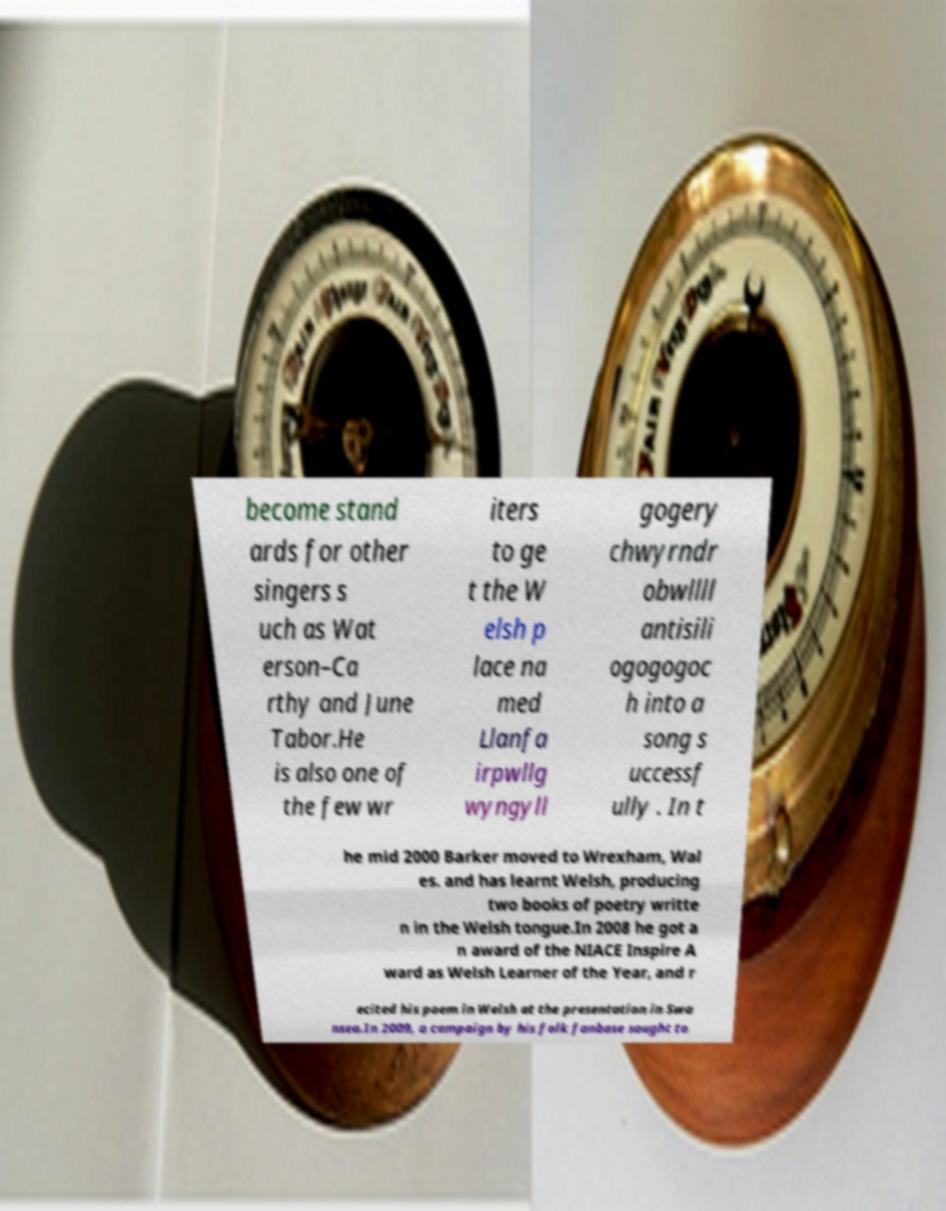There's text embedded in this image that I need extracted. Can you transcribe it verbatim? become stand ards for other singers s uch as Wat erson–Ca rthy and June Tabor.He is also one of the few wr iters to ge t the W elsh p lace na med Llanfa irpwllg wyngyll gogery chwyrndr obwllll antisili ogogogoc h into a song s uccessf ully . In t he mid 2000 Barker moved to Wrexham, Wal es. and has learnt Welsh, producing two books of poetry writte n in the Welsh tongue.In 2008 he got a n award of the NIACE Inspire A ward as Welsh Learner of the Year, and r ecited his poem in Welsh at the presentation in Swa nsea.In 2009, a campaign by his folk fanbase sought to 